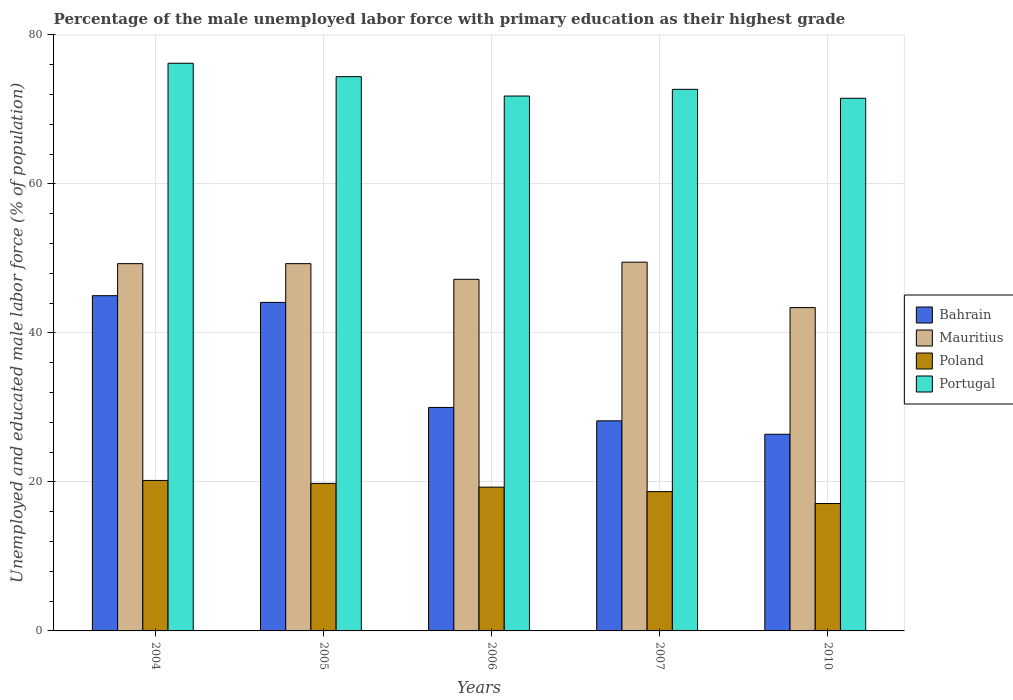How many groups of bars are there?
Your answer should be very brief. 5. How many bars are there on the 5th tick from the left?
Your answer should be compact. 4. How many bars are there on the 3rd tick from the right?
Offer a terse response. 4. What is the label of the 1st group of bars from the left?
Provide a succinct answer. 2004. In how many cases, is the number of bars for a given year not equal to the number of legend labels?
Make the answer very short. 0. Across all years, what is the maximum percentage of the unemployed male labor force with primary education in Poland?
Offer a terse response. 20.2. Across all years, what is the minimum percentage of the unemployed male labor force with primary education in Bahrain?
Provide a succinct answer. 26.4. In which year was the percentage of the unemployed male labor force with primary education in Poland maximum?
Offer a terse response. 2004. What is the total percentage of the unemployed male labor force with primary education in Portugal in the graph?
Offer a very short reply. 366.6. What is the difference between the percentage of the unemployed male labor force with primary education in Mauritius in 2004 and that in 2010?
Your answer should be very brief. 5.9. What is the difference between the percentage of the unemployed male labor force with primary education in Portugal in 2005 and the percentage of the unemployed male labor force with primary education in Bahrain in 2004?
Keep it short and to the point. 29.4. What is the average percentage of the unemployed male labor force with primary education in Mauritius per year?
Your answer should be compact. 47.74. In the year 2007, what is the difference between the percentage of the unemployed male labor force with primary education in Portugal and percentage of the unemployed male labor force with primary education in Mauritius?
Ensure brevity in your answer.  23.2. What is the ratio of the percentage of the unemployed male labor force with primary education in Mauritius in 2004 to that in 2010?
Your response must be concise. 1.14. Is the difference between the percentage of the unemployed male labor force with primary education in Portugal in 2005 and 2010 greater than the difference between the percentage of the unemployed male labor force with primary education in Mauritius in 2005 and 2010?
Offer a terse response. No. What is the difference between the highest and the second highest percentage of the unemployed male labor force with primary education in Mauritius?
Make the answer very short. 0.2. What is the difference between the highest and the lowest percentage of the unemployed male labor force with primary education in Portugal?
Keep it short and to the point. 4.7. Is the sum of the percentage of the unemployed male labor force with primary education in Poland in 2005 and 2007 greater than the maximum percentage of the unemployed male labor force with primary education in Mauritius across all years?
Give a very brief answer. No. Is it the case that in every year, the sum of the percentage of the unemployed male labor force with primary education in Poland and percentage of the unemployed male labor force with primary education in Mauritius is greater than the sum of percentage of the unemployed male labor force with primary education in Portugal and percentage of the unemployed male labor force with primary education in Bahrain?
Make the answer very short. No. What does the 1st bar from the left in 2005 represents?
Give a very brief answer. Bahrain. What does the 4th bar from the right in 2006 represents?
Offer a terse response. Bahrain. Is it the case that in every year, the sum of the percentage of the unemployed male labor force with primary education in Poland and percentage of the unemployed male labor force with primary education in Bahrain is greater than the percentage of the unemployed male labor force with primary education in Portugal?
Give a very brief answer. No. Are all the bars in the graph horizontal?
Give a very brief answer. No. How many years are there in the graph?
Keep it short and to the point. 5. Are the values on the major ticks of Y-axis written in scientific E-notation?
Your response must be concise. No. How are the legend labels stacked?
Your response must be concise. Vertical. What is the title of the graph?
Provide a short and direct response. Percentage of the male unemployed labor force with primary education as their highest grade. What is the label or title of the Y-axis?
Your response must be concise. Unemployed and educated male labor force (% of population). What is the Unemployed and educated male labor force (% of population) in Mauritius in 2004?
Offer a very short reply. 49.3. What is the Unemployed and educated male labor force (% of population) of Poland in 2004?
Offer a very short reply. 20.2. What is the Unemployed and educated male labor force (% of population) of Portugal in 2004?
Provide a short and direct response. 76.2. What is the Unemployed and educated male labor force (% of population) in Bahrain in 2005?
Give a very brief answer. 44.1. What is the Unemployed and educated male labor force (% of population) in Mauritius in 2005?
Make the answer very short. 49.3. What is the Unemployed and educated male labor force (% of population) in Poland in 2005?
Provide a short and direct response. 19.8. What is the Unemployed and educated male labor force (% of population) of Portugal in 2005?
Provide a short and direct response. 74.4. What is the Unemployed and educated male labor force (% of population) of Bahrain in 2006?
Ensure brevity in your answer.  30. What is the Unemployed and educated male labor force (% of population) in Mauritius in 2006?
Your answer should be compact. 47.2. What is the Unemployed and educated male labor force (% of population) of Poland in 2006?
Provide a succinct answer. 19.3. What is the Unemployed and educated male labor force (% of population) in Portugal in 2006?
Make the answer very short. 71.8. What is the Unemployed and educated male labor force (% of population) in Bahrain in 2007?
Offer a very short reply. 28.2. What is the Unemployed and educated male labor force (% of population) in Mauritius in 2007?
Offer a very short reply. 49.5. What is the Unemployed and educated male labor force (% of population) of Poland in 2007?
Make the answer very short. 18.7. What is the Unemployed and educated male labor force (% of population) of Portugal in 2007?
Ensure brevity in your answer.  72.7. What is the Unemployed and educated male labor force (% of population) in Bahrain in 2010?
Make the answer very short. 26.4. What is the Unemployed and educated male labor force (% of population) in Mauritius in 2010?
Your response must be concise. 43.4. What is the Unemployed and educated male labor force (% of population) in Poland in 2010?
Your answer should be compact. 17.1. What is the Unemployed and educated male labor force (% of population) of Portugal in 2010?
Your answer should be compact. 71.5. Across all years, what is the maximum Unemployed and educated male labor force (% of population) in Mauritius?
Your response must be concise. 49.5. Across all years, what is the maximum Unemployed and educated male labor force (% of population) in Poland?
Offer a terse response. 20.2. Across all years, what is the maximum Unemployed and educated male labor force (% of population) of Portugal?
Your response must be concise. 76.2. Across all years, what is the minimum Unemployed and educated male labor force (% of population) of Bahrain?
Offer a very short reply. 26.4. Across all years, what is the minimum Unemployed and educated male labor force (% of population) of Mauritius?
Ensure brevity in your answer.  43.4. Across all years, what is the minimum Unemployed and educated male labor force (% of population) in Poland?
Your response must be concise. 17.1. Across all years, what is the minimum Unemployed and educated male labor force (% of population) in Portugal?
Offer a very short reply. 71.5. What is the total Unemployed and educated male labor force (% of population) of Bahrain in the graph?
Ensure brevity in your answer.  173.7. What is the total Unemployed and educated male labor force (% of population) of Mauritius in the graph?
Provide a short and direct response. 238.7. What is the total Unemployed and educated male labor force (% of population) of Poland in the graph?
Give a very brief answer. 95.1. What is the total Unemployed and educated male labor force (% of population) in Portugal in the graph?
Give a very brief answer. 366.6. What is the difference between the Unemployed and educated male labor force (% of population) in Bahrain in 2004 and that in 2005?
Your answer should be compact. 0.9. What is the difference between the Unemployed and educated male labor force (% of population) in Portugal in 2004 and that in 2005?
Offer a terse response. 1.8. What is the difference between the Unemployed and educated male labor force (% of population) of Poland in 2004 and that in 2006?
Offer a terse response. 0.9. What is the difference between the Unemployed and educated male labor force (% of population) in Portugal in 2004 and that in 2006?
Provide a succinct answer. 4.4. What is the difference between the Unemployed and educated male labor force (% of population) in Poland in 2004 and that in 2007?
Your response must be concise. 1.5. What is the difference between the Unemployed and educated male labor force (% of population) in Portugal in 2004 and that in 2007?
Give a very brief answer. 3.5. What is the difference between the Unemployed and educated male labor force (% of population) of Bahrain in 2004 and that in 2010?
Keep it short and to the point. 18.6. What is the difference between the Unemployed and educated male labor force (% of population) of Mauritius in 2004 and that in 2010?
Provide a short and direct response. 5.9. What is the difference between the Unemployed and educated male labor force (% of population) in Mauritius in 2005 and that in 2006?
Keep it short and to the point. 2.1. What is the difference between the Unemployed and educated male labor force (% of population) in Poland in 2005 and that in 2006?
Your answer should be very brief. 0.5. What is the difference between the Unemployed and educated male labor force (% of population) of Portugal in 2005 and that in 2006?
Offer a very short reply. 2.6. What is the difference between the Unemployed and educated male labor force (% of population) of Mauritius in 2005 and that in 2007?
Provide a short and direct response. -0.2. What is the difference between the Unemployed and educated male labor force (% of population) in Poland in 2005 and that in 2007?
Ensure brevity in your answer.  1.1. What is the difference between the Unemployed and educated male labor force (% of population) in Bahrain in 2006 and that in 2007?
Offer a very short reply. 1.8. What is the difference between the Unemployed and educated male labor force (% of population) of Bahrain in 2006 and that in 2010?
Provide a short and direct response. 3.6. What is the difference between the Unemployed and educated male labor force (% of population) of Portugal in 2006 and that in 2010?
Provide a short and direct response. 0.3. What is the difference between the Unemployed and educated male labor force (% of population) in Bahrain in 2007 and that in 2010?
Make the answer very short. 1.8. What is the difference between the Unemployed and educated male labor force (% of population) of Mauritius in 2007 and that in 2010?
Make the answer very short. 6.1. What is the difference between the Unemployed and educated male labor force (% of population) of Poland in 2007 and that in 2010?
Your response must be concise. 1.6. What is the difference between the Unemployed and educated male labor force (% of population) of Bahrain in 2004 and the Unemployed and educated male labor force (% of population) of Mauritius in 2005?
Make the answer very short. -4.3. What is the difference between the Unemployed and educated male labor force (% of population) of Bahrain in 2004 and the Unemployed and educated male labor force (% of population) of Poland in 2005?
Your response must be concise. 25.2. What is the difference between the Unemployed and educated male labor force (% of population) of Bahrain in 2004 and the Unemployed and educated male labor force (% of population) of Portugal in 2005?
Provide a succinct answer. -29.4. What is the difference between the Unemployed and educated male labor force (% of population) of Mauritius in 2004 and the Unemployed and educated male labor force (% of population) of Poland in 2005?
Make the answer very short. 29.5. What is the difference between the Unemployed and educated male labor force (% of population) of Mauritius in 2004 and the Unemployed and educated male labor force (% of population) of Portugal in 2005?
Provide a short and direct response. -25.1. What is the difference between the Unemployed and educated male labor force (% of population) of Poland in 2004 and the Unemployed and educated male labor force (% of population) of Portugal in 2005?
Ensure brevity in your answer.  -54.2. What is the difference between the Unemployed and educated male labor force (% of population) of Bahrain in 2004 and the Unemployed and educated male labor force (% of population) of Mauritius in 2006?
Make the answer very short. -2.2. What is the difference between the Unemployed and educated male labor force (% of population) in Bahrain in 2004 and the Unemployed and educated male labor force (% of population) in Poland in 2006?
Provide a succinct answer. 25.7. What is the difference between the Unemployed and educated male labor force (% of population) of Bahrain in 2004 and the Unemployed and educated male labor force (% of population) of Portugal in 2006?
Provide a short and direct response. -26.8. What is the difference between the Unemployed and educated male labor force (% of population) in Mauritius in 2004 and the Unemployed and educated male labor force (% of population) in Poland in 2006?
Make the answer very short. 30. What is the difference between the Unemployed and educated male labor force (% of population) in Mauritius in 2004 and the Unemployed and educated male labor force (% of population) in Portugal in 2006?
Give a very brief answer. -22.5. What is the difference between the Unemployed and educated male labor force (% of population) of Poland in 2004 and the Unemployed and educated male labor force (% of population) of Portugal in 2006?
Your answer should be very brief. -51.6. What is the difference between the Unemployed and educated male labor force (% of population) in Bahrain in 2004 and the Unemployed and educated male labor force (% of population) in Poland in 2007?
Your response must be concise. 26.3. What is the difference between the Unemployed and educated male labor force (% of population) in Bahrain in 2004 and the Unemployed and educated male labor force (% of population) in Portugal in 2007?
Make the answer very short. -27.7. What is the difference between the Unemployed and educated male labor force (% of population) in Mauritius in 2004 and the Unemployed and educated male labor force (% of population) in Poland in 2007?
Your response must be concise. 30.6. What is the difference between the Unemployed and educated male labor force (% of population) in Mauritius in 2004 and the Unemployed and educated male labor force (% of population) in Portugal in 2007?
Your answer should be very brief. -23.4. What is the difference between the Unemployed and educated male labor force (% of population) of Poland in 2004 and the Unemployed and educated male labor force (% of population) of Portugal in 2007?
Give a very brief answer. -52.5. What is the difference between the Unemployed and educated male labor force (% of population) in Bahrain in 2004 and the Unemployed and educated male labor force (% of population) in Poland in 2010?
Your response must be concise. 27.9. What is the difference between the Unemployed and educated male labor force (% of population) in Bahrain in 2004 and the Unemployed and educated male labor force (% of population) in Portugal in 2010?
Provide a short and direct response. -26.5. What is the difference between the Unemployed and educated male labor force (% of population) of Mauritius in 2004 and the Unemployed and educated male labor force (% of population) of Poland in 2010?
Offer a terse response. 32.2. What is the difference between the Unemployed and educated male labor force (% of population) in Mauritius in 2004 and the Unemployed and educated male labor force (% of population) in Portugal in 2010?
Ensure brevity in your answer.  -22.2. What is the difference between the Unemployed and educated male labor force (% of population) in Poland in 2004 and the Unemployed and educated male labor force (% of population) in Portugal in 2010?
Your response must be concise. -51.3. What is the difference between the Unemployed and educated male labor force (% of population) in Bahrain in 2005 and the Unemployed and educated male labor force (% of population) in Mauritius in 2006?
Offer a terse response. -3.1. What is the difference between the Unemployed and educated male labor force (% of population) in Bahrain in 2005 and the Unemployed and educated male labor force (% of population) in Poland in 2006?
Offer a very short reply. 24.8. What is the difference between the Unemployed and educated male labor force (% of population) in Bahrain in 2005 and the Unemployed and educated male labor force (% of population) in Portugal in 2006?
Your answer should be very brief. -27.7. What is the difference between the Unemployed and educated male labor force (% of population) of Mauritius in 2005 and the Unemployed and educated male labor force (% of population) of Poland in 2006?
Your answer should be very brief. 30. What is the difference between the Unemployed and educated male labor force (% of population) in Mauritius in 2005 and the Unemployed and educated male labor force (% of population) in Portugal in 2006?
Ensure brevity in your answer.  -22.5. What is the difference between the Unemployed and educated male labor force (% of population) in Poland in 2005 and the Unemployed and educated male labor force (% of population) in Portugal in 2006?
Make the answer very short. -52. What is the difference between the Unemployed and educated male labor force (% of population) in Bahrain in 2005 and the Unemployed and educated male labor force (% of population) in Poland in 2007?
Keep it short and to the point. 25.4. What is the difference between the Unemployed and educated male labor force (% of population) of Bahrain in 2005 and the Unemployed and educated male labor force (% of population) of Portugal in 2007?
Provide a succinct answer. -28.6. What is the difference between the Unemployed and educated male labor force (% of population) of Mauritius in 2005 and the Unemployed and educated male labor force (% of population) of Poland in 2007?
Provide a short and direct response. 30.6. What is the difference between the Unemployed and educated male labor force (% of population) of Mauritius in 2005 and the Unemployed and educated male labor force (% of population) of Portugal in 2007?
Make the answer very short. -23.4. What is the difference between the Unemployed and educated male labor force (% of population) of Poland in 2005 and the Unemployed and educated male labor force (% of population) of Portugal in 2007?
Give a very brief answer. -52.9. What is the difference between the Unemployed and educated male labor force (% of population) of Bahrain in 2005 and the Unemployed and educated male labor force (% of population) of Poland in 2010?
Provide a short and direct response. 27. What is the difference between the Unemployed and educated male labor force (% of population) in Bahrain in 2005 and the Unemployed and educated male labor force (% of population) in Portugal in 2010?
Provide a short and direct response. -27.4. What is the difference between the Unemployed and educated male labor force (% of population) of Mauritius in 2005 and the Unemployed and educated male labor force (% of population) of Poland in 2010?
Ensure brevity in your answer.  32.2. What is the difference between the Unemployed and educated male labor force (% of population) in Mauritius in 2005 and the Unemployed and educated male labor force (% of population) in Portugal in 2010?
Provide a succinct answer. -22.2. What is the difference between the Unemployed and educated male labor force (% of population) in Poland in 2005 and the Unemployed and educated male labor force (% of population) in Portugal in 2010?
Give a very brief answer. -51.7. What is the difference between the Unemployed and educated male labor force (% of population) in Bahrain in 2006 and the Unemployed and educated male labor force (% of population) in Mauritius in 2007?
Provide a succinct answer. -19.5. What is the difference between the Unemployed and educated male labor force (% of population) in Bahrain in 2006 and the Unemployed and educated male labor force (% of population) in Poland in 2007?
Give a very brief answer. 11.3. What is the difference between the Unemployed and educated male labor force (% of population) of Bahrain in 2006 and the Unemployed and educated male labor force (% of population) of Portugal in 2007?
Offer a very short reply. -42.7. What is the difference between the Unemployed and educated male labor force (% of population) in Mauritius in 2006 and the Unemployed and educated male labor force (% of population) in Portugal in 2007?
Ensure brevity in your answer.  -25.5. What is the difference between the Unemployed and educated male labor force (% of population) of Poland in 2006 and the Unemployed and educated male labor force (% of population) of Portugal in 2007?
Your response must be concise. -53.4. What is the difference between the Unemployed and educated male labor force (% of population) of Bahrain in 2006 and the Unemployed and educated male labor force (% of population) of Mauritius in 2010?
Make the answer very short. -13.4. What is the difference between the Unemployed and educated male labor force (% of population) of Bahrain in 2006 and the Unemployed and educated male labor force (% of population) of Portugal in 2010?
Keep it short and to the point. -41.5. What is the difference between the Unemployed and educated male labor force (% of population) in Mauritius in 2006 and the Unemployed and educated male labor force (% of population) in Poland in 2010?
Keep it short and to the point. 30.1. What is the difference between the Unemployed and educated male labor force (% of population) in Mauritius in 2006 and the Unemployed and educated male labor force (% of population) in Portugal in 2010?
Your answer should be very brief. -24.3. What is the difference between the Unemployed and educated male labor force (% of population) of Poland in 2006 and the Unemployed and educated male labor force (% of population) of Portugal in 2010?
Provide a short and direct response. -52.2. What is the difference between the Unemployed and educated male labor force (% of population) in Bahrain in 2007 and the Unemployed and educated male labor force (% of population) in Mauritius in 2010?
Your answer should be very brief. -15.2. What is the difference between the Unemployed and educated male labor force (% of population) of Bahrain in 2007 and the Unemployed and educated male labor force (% of population) of Portugal in 2010?
Offer a very short reply. -43.3. What is the difference between the Unemployed and educated male labor force (% of population) of Mauritius in 2007 and the Unemployed and educated male labor force (% of population) of Poland in 2010?
Offer a very short reply. 32.4. What is the difference between the Unemployed and educated male labor force (% of population) in Poland in 2007 and the Unemployed and educated male labor force (% of population) in Portugal in 2010?
Offer a very short reply. -52.8. What is the average Unemployed and educated male labor force (% of population) of Bahrain per year?
Offer a terse response. 34.74. What is the average Unemployed and educated male labor force (% of population) of Mauritius per year?
Your answer should be compact. 47.74. What is the average Unemployed and educated male labor force (% of population) of Poland per year?
Your answer should be very brief. 19.02. What is the average Unemployed and educated male labor force (% of population) in Portugal per year?
Your answer should be very brief. 73.32. In the year 2004, what is the difference between the Unemployed and educated male labor force (% of population) of Bahrain and Unemployed and educated male labor force (% of population) of Poland?
Your answer should be compact. 24.8. In the year 2004, what is the difference between the Unemployed and educated male labor force (% of population) in Bahrain and Unemployed and educated male labor force (% of population) in Portugal?
Provide a short and direct response. -31.2. In the year 2004, what is the difference between the Unemployed and educated male labor force (% of population) in Mauritius and Unemployed and educated male labor force (% of population) in Poland?
Offer a very short reply. 29.1. In the year 2004, what is the difference between the Unemployed and educated male labor force (% of population) in Mauritius and Unemployed and educated male labor force (% of population) in Portugal?
Give a very brief answer. -26.9. In the year 2004, what is the difference between the Unemployed and educated male labor force (% of population) of Poland and Unemployed and educated male labor force (% of population) of Portugal?
Ensure brevity in your answer.  -56. In the year 2005, what is the difference between the Unemployed and educated male labor force (% of population) in Bahrain and Unemployed and educated male labor force (% of population) in Mauritius?
Offer a very short reply. -5.2. In the year 2005, what is the difference between the Unemployed and educated male labor force (% of population) in Bahrain and Unemployed and educated male labor force (% of population) in Poland?
Your response must be concise. 24.3. In the year 2005, what is the difference between the Unemployed and educated male labor force (% of population) in Bahrain and Unemployed and educated male labor force (% of population) in Portugal?
Offer a terse response. -30.3. In the year 2005, what is the difference between the Unemployed and educated male labor force (% of population) in Mauritius and Unemployed and educated male labor force (% of population) in Poland?
Offer a very short reply. 29.5. In the year 2005, what is the difference between the Unemployed and educated male labor force (% of population) in Mauritius and Unemployed and educated male labor force (% of population) in Portugal?
Your response must be concise. -25.1. In the year 2005, what is the difference between the Unemployed and educated male labor force (% of population) in Poland and Unemployed and educated male labor force (% of population) in Portugal?
Provide a short and direct response. -54.6. In the year 2006, what is the difference between the Unemployed and educated male labor force (% of population) in Bahrain and Unemployed and educated male labor force (% of population) in Mauritius?
Ensure brevity in your answer.  -17.2. In the year 2006, what is the difference between the Unemployed and educated male labor force (% of population) of Bahrain and Unemployed and educated male labor force (% of population) of Portugal?
Offer a very short reply. -41.8. In the year 2006, what is the difference between the Unemployed and educated male labor force (% of population) of Mauritius and Unemployed and educated male labor force (% of population) of Poland?
Keep it short and to the point. 27.9. In the year 2006, what is the difference between the Unemployed and educated male labor force (% of population) in Mauritius and Unemployed and educated male labor force (% of population) in Portugal?
Your response must be concise. -24.6. In the year 2006, what is the difference between the Unemployed and educated male labor force (% of population) of Poland and Unemployed and educated male labor force (% of population) of Portugal?
Provide a succinct answer. -52.5. In the year 2007, what is the difference between the Unemployed and educated male labor force (% of population) in Bahrain and Unemployed and educated male labor force (% of population) in Mauritius?
Your answer should be very brief. -21.3. In the year 2007, what is the difference between the Unemployed and educated male labor force (% of population) in Bahrain and Unemployed and educated male labor force (% of population) in Poland?
Provide a succinct answer. 9.5. In the year 2007, what is the difference between the Unemployed and educated male labor force (% of population) in Bahrain and Unemployed and educated male labor force (% of population) in Portugal?
Your answer should be very brief. -44.5. In the year 2007, what is the difference between the Unemployed and educated male labor force (% of population) of Mauritius and Unemployed and educated male labor force (% of population) of Poland?
Give a very brief answer. 30.8. In the year 2007, what is the difference between the Unemployed and educated male labor force (% of population) of Mauritius and Unemployed and educated male labor force (% of population) of Portugal?
Offer a terse response. -23.2. In the year 2007, what is the difference between the Unemployed and educated male labor force (% of population) in Poland and Unemployed and educated male labor force (% of population) in Portugal?
Ensure brevity in your answer.  -54. In the year 2010, what is the difference between the Unemployed and educated male labor force (% of population) in Bahrain and Unemployed and educated male labor force (% of population) in Poland?
Give a very brief answer. 9.3. In the year 2010, what is the difference between the Unemployed and educated male labor force (% of population) in Bahrain and Unemployed and educated male labor force (% of population) in Portugal?
Make the answer very short. -45.1. In the year 2010, what is the difference between the Unemployed and educated male labor force (% of population) in Mauritius and Unemployed and educated male labor force (% of population) in Poland?
Your answer should be compact. 26.3. In the year 2010, what is the difference between the Unemployed and educated male labor force (% of population) of Mauritius and Unemployed and educated male labor force (% of population) of Portugal?
Your answer should be very brief. -28.1. In the year 2010, what is the difference between the Unemployed and educated male labor force (% of population) of Poland and Unemployed and educated male labor force (% of population) of Portugal?
Your answer should be very brief. -54.4. What is the ratio of the Unemployed and educated male labor force (% of population) of Bahrain in 2004 to that in 2005?
Your answer should be very brief. 1.02. What is the ratio of the Unemployed and educated male labor force (% of population) in Mauritius in 2004 to that in 2005?
Provide a short and direct response. 1. What is the ratio of the Unemployed and educated male labor force (% of population) in Poland in 2004 to that in 2005?
Your answer should be very brief. 1.02. What is the ratio of the Unemployed and educated male labor force (% of population) in Portugal in 2004 to that in 2005?
Ensure brevity in your answer.  1.02. What is the ratio of the Unemployed and educated male labor force (% of population) in Mauritius in 2004 to that in 2006?
Your answer should be compact. 1.04. What is the ratio of the Unemployed and educated male labor force (% of population) of Poland in 2004 to that in 2006?
Make the answer very short. 1.05. What is the ratio of the Unemployed and educated male labor force (% of population) in Portugal in 2004 to that in 2006?
Your answer should be compact. 1.06. What is the ratio of the Unemployed and educated male labor force (% of population) of Bahrain in 2004 to that in 2007?
Give a very brief answer. 1.6. What is the ratio of the Unemployed and educated male labor force (% of population) in Mauritius in 2004 to that in 2007?
Make the answer very short. 1. What is the ratio of the Unemployed and educated male labor force (% of population) in Poland in 2004 to that in 2007?
Offer a terse response. 1.08. What is the ratio of the Unemployed and educated male labor force (% of population) in Portugal in 2004 to that in 2007?
Ensure brevity in your answer.  1.05. What is the ratio of the Unemployed and educated male labor force (% of population) of Bahrain in 2004 to that in 2010?
Provide a succinct answer. 1.7. What is the ratio of the Unemployed and educated male labor force (% of population) of Mauritius in 2004 to that in 2010?
Give a very brief answer. 1.14. What is the ratio of the Unemployed and educated male labor force (% of population) of Poland in 2004 to that in 2010?
Give a very brief answer. 1.18. What is the ratio of the Unemployed and educated male labor force (% of population) in Portugal in 2004 to that in 2010?
Keep it short and to the point. 1.07. What is the ratio of the Unemployed and educated male labor force (% of population) of Bahrain in 2005 to that in 2006?
Offer a terse response. 1.47. What is the ratio of the Unemployed and educated male labor force (% of population) in Mauritius in 2005 to that in 2006?
Offer a very short reply. 1.04. What is the ratio of the Unemployed and educated male labor force (% of population) in Poland in 2005 to that in 2006?
Your answer should be compact. 1.03. What is the ratio of the Unemployed and educated male labor force (% of population) of Portugal in 2005 to that in 2006?
Your response must be concise. 1.04. What is the ratio of the Unemployed and educated male labor force (% of population) in Bahrain in 2005 to that in 2007?
Your answer should be compact. 1.56. What is the ratio of the Unemployed and educated male labor force (% of population) in Poland in 2005 to that in 2007?
Offer a very short reply. 1.06. What is the ratio of the Unemployed and educated male labor force (% of population) of Portugal in 2005 to that in 2007?
Provide a short and direct response. 1.02. What is the ratio of the Unemployed and educated male labor force (% of population) of Bahrain in 2005 to that in 2010?
Offer a very short reply. 1.67. What is the ratio of the Unemployed and educated male labor force (% of population) in Mauritius in 2005 to that in 2010?
Offer a very short reply. 1.14. What is the ratio of the Unemployed and educated male labor force (% of population) of Poland in 2005 to that in 2010?
Your answer should be very brief. 1.16. What is the ratio of the Unemployed and educated male labor force (% of population) of Portugal in 2005 to that in 2010?
Your answer should be very brief. 1.04. What is the ratio of the Unemployed and educated male labor force (% of population) in Bahrain in 2006 to that in 2007?
Make the answer very short. 1.06. What is the ratio of the Unemployed and educated male labor force (% of population) of Mauritius in 2006 to that in 2007?
Provide a succinct answer. 0.95. What is the ratio of the Unemployed and educated male labor force (% of population) of Poland in 2006 to that in 2007?
Ensure brevity in your answer.  1.03. What is the ratio of the Unemployed and educated male labor force (% of population) of Portugal in 2006 to that in 2007?
Offer a terse response. 0.99. What is the ratio of the Unemployed and educated male labor force (% of population) in Bahrain in 2006 to that in 2010?
Provide a short and direct response. 1.14. What is the ratio of the Unemployed and educated male labor force (% of population) in Mauritius in 2006 to that in 2010?
Keep it short and to the point. 1.09. What is the ratio of the Unemployed and educated male labor force (% of population) in Poland in 2006 to that in 2010?
Ensure brevity in your answer.  1.13. What is the ratio of the Unemployed and educated male labor force (% of population) in Portugal in 2006 to that in 2010?
Provide a succinct answer. 1. What is the ratio of the Unemployed and educated male labor force (% of population) in Bahrain in 2007 to that in 2010?
Your answer should be very brief. 1.07. What is the ratio of the Unemployed and educated male labor force (% of population) of Mauritius in 2007 to that in 2010?
Your response must be concise. 1.14. What is the ratio of the Unemployed and educated male labor force (% of population) in Poland in 2007 to that in 2010?
Ensure brevity in your answer.  1.09. What is the ratio of the Unemployed and educated male labor force (% of population) of Portugal in 2007 to that in 2010?
Make the answer very short. 1.02. What is the difference between the highest and the second highest Unemployed and educated male labor force (% of population) in Poland?
Ensure brevity in your answer.  0.4. 